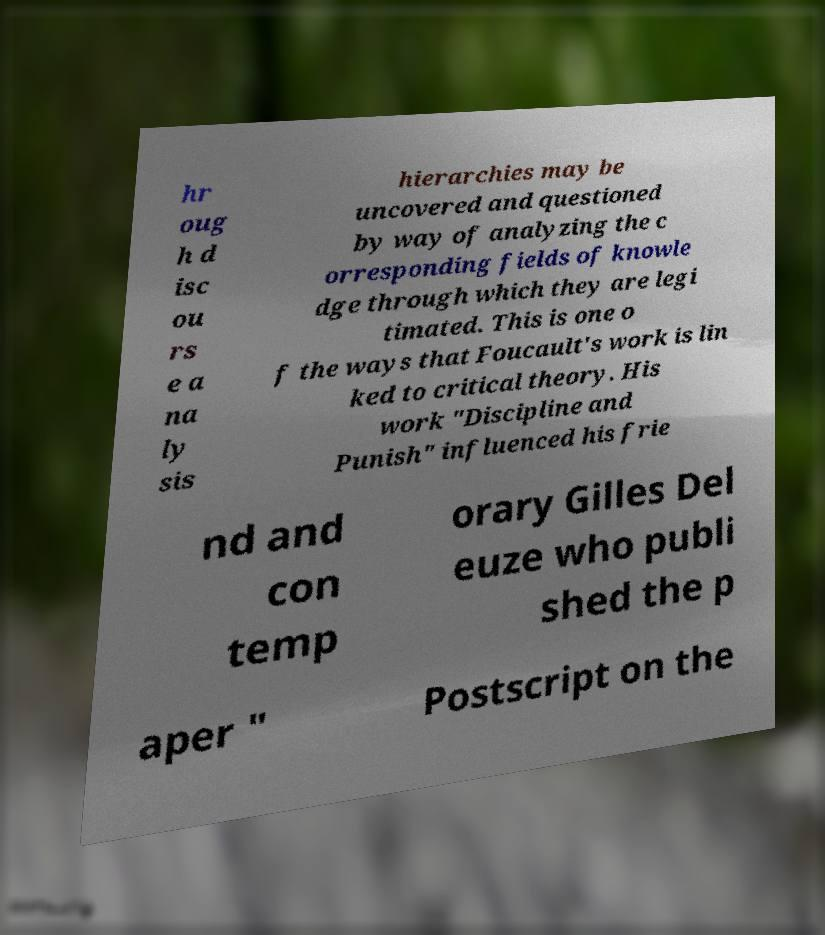I need the written content from this picture converted into text. Can you do that? hr oug h d isc ou rs e a na ly sis hierarchies may be uncovered and questioned by way of analyzing the c orresponding fields of knowle dge through which they are legi timated. This is one o f the ways that Foucault's work is lin ked to critical theory. His work "Discipline and Punish" influenced his frie nd and con temp orary Gilles Del euze who publi shed the p aper " Postscript on the 